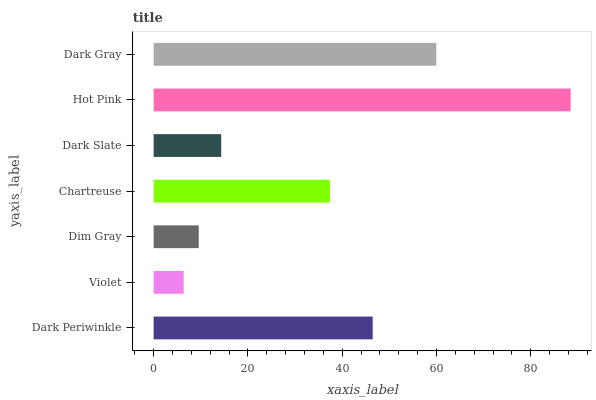Is Violet the minimum?
Answer yes or no. Yes. Is Hot Pink the maximum?
Answer yes or no. Yes. Is Dim Gray the minimum?
Answer yes or no. No. Is Dim Gray the maximum?
Answer yes or no. No. Is Dim Gray greater than Violet?
Answer yes or no. Yes. Is Violet less than Dim Gray?
Answer yes or no. Yes. Is Violet greater than Dim Gray?
Answer yes or no. No. Is Dim Gray less than Violet?
Answer yes or no. No. Is Chartreuse the high median?
Answer yes or no. Yes. Is Chartreuse the low median?
Answer yes or no. Yes. Is Dark Slate the high median?
Answer yes or no. No. Is Hot Pink the low median?
Answer yes or no. No. 